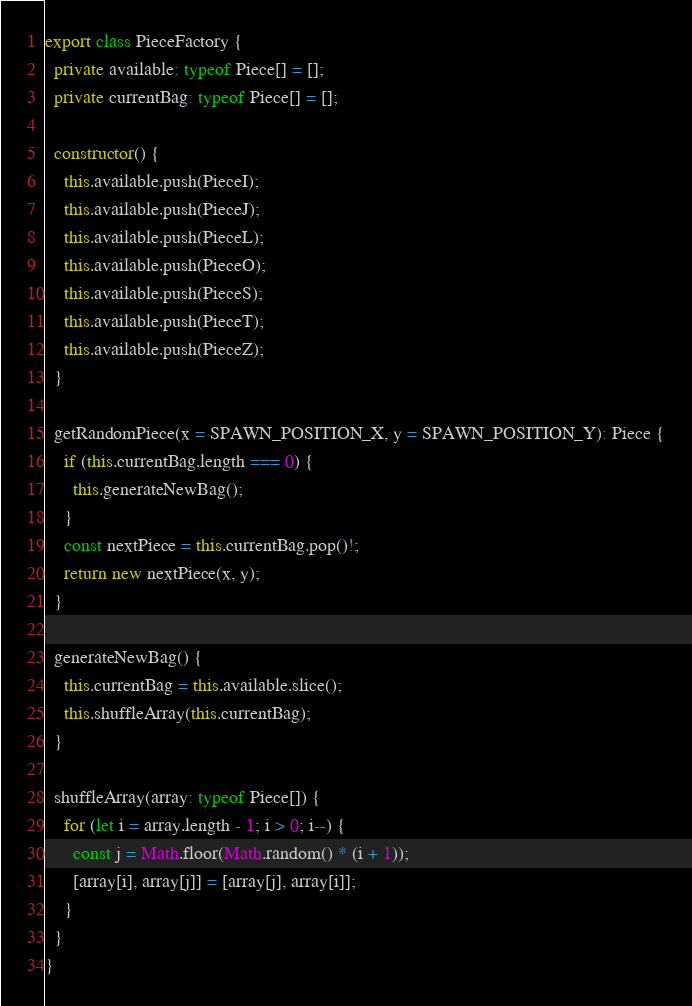Convert code to text. <code><loc_0><loc_0><loc_500><loc_500><_TypeScript_>export class PieceFactory {
  private available: typeof Piece[] = [];
  private currentBag: typeof Piece[] = [];

  constructor() {
    this.available.push(PieceI);
    this.available.push(PieceJ);
    this.available.push(PieceL);
    this.available.push(PieceO);
    this.available.push(PieceS);
    this.available.push(PieceT);
    this.available.push(PieceZ);
  }

  getRandomPiece(x = SPAWN_POSITION_X, y = SPAWN_POSITION_Y): Piece {
    if (this.currentBag.length === 0) {
      this.generateNewBag();
    }
    const nextPiece = this.currentBag.pop()!;
    return new nextPiece(x, y);
  }

  generateNewBag() {
    this.currentBag = this.available.slice();
    this.shuffleArray(this.currentBag);
  }

  shuffleArray(array: typeof Piece[]) {
    for (let i = array.length - 1; i > 0; i--) {
      const j = Math.floor(Math.random() * (i + 1));
      [array[i], array[j]] = [array[j], array[i]];
    }
  }
}
</code> 